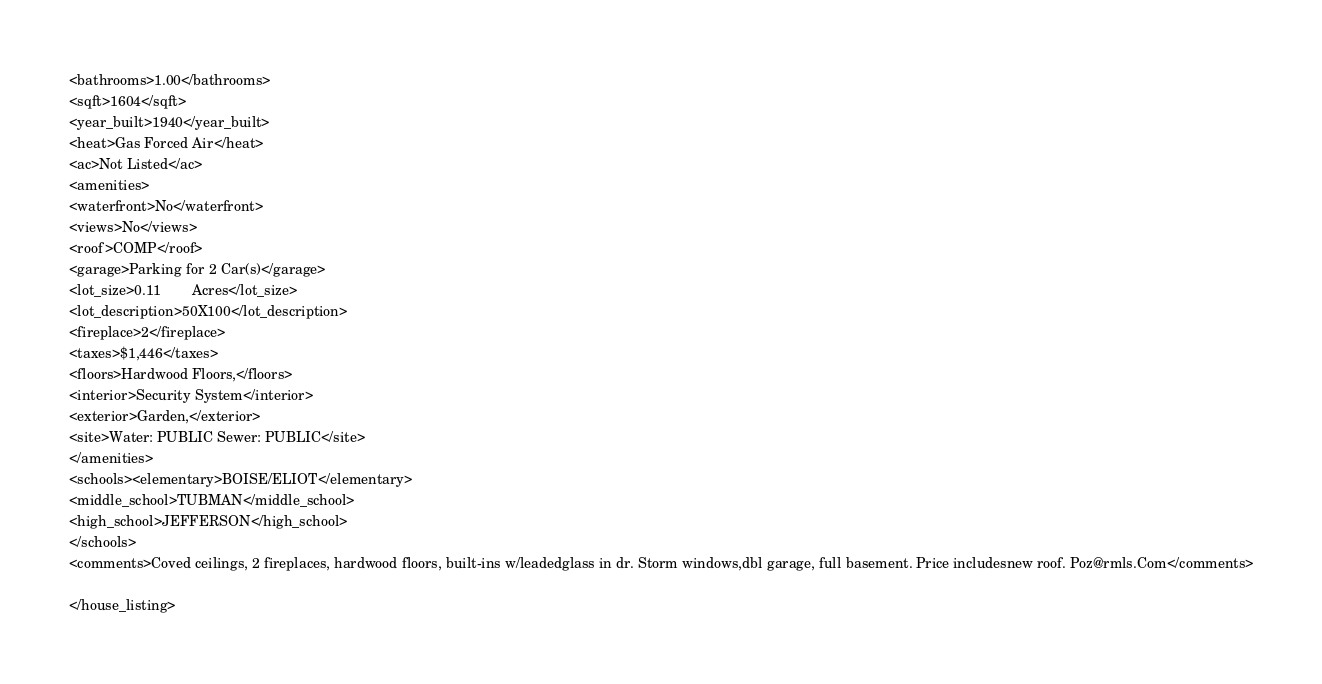<code> <loc_0><loc_0><loc_500><loc_500><_XML_><bathrooms>1.00</bathrooms>
<sqft>1604</sqft>
<year_built>1940</year_built>
<heat>Gas Forced Air</heat>
<ac>Not Listed</ac>
<amenities>
<waterfront>No</waterfront>
<views>No</views>
<roof>COMP</roof>
<garage>Parking for 2 Car(s)</garage>
<lot_size>0.11        Acres</lot_size>
<lot_description>50X100</lot_description>
<fireplace>2</fireplace>
<taxes>$1,446</taxes>
<floors>Hardwood Floors,</floors>
<interior>Security System</interior>
<exterior>Garden,</exterior>
<site>Water: PUBLIC Sewer: PUBLIC</site>
</amenities>
<schools><elementary>BOISE/ELIOT</elementary>
<middle_school>TUBMAN</middle_school>
<high_school>JEFFERSON</high_school>
</schools>
<comments>Coved ceilings, 2 fireplaces, hardwood floors, built-ins w/leadedglass in dr. Storm windows,dbl garage, full basement. Price includesnew roof. Poz@rmls.Com</comments>

</house_listing>



</code> 